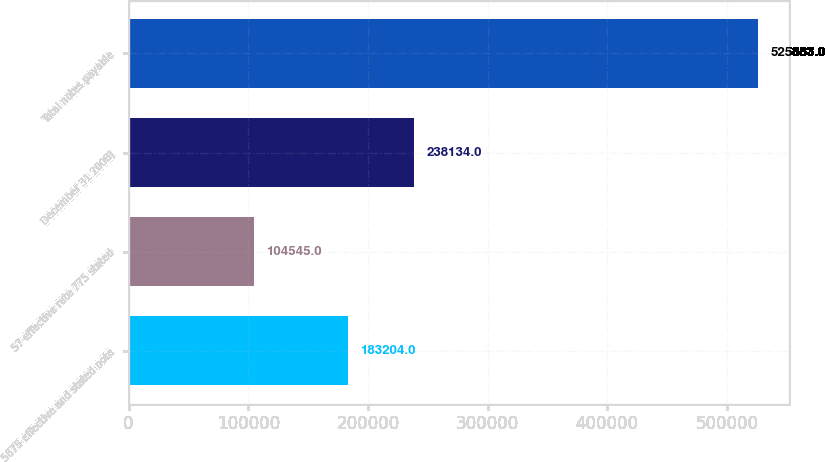Convert chart to OTSL. <chart><loc_0><loc_0><loc_500><loc_500><bar_chart><fcel>5875 effective and stated note<fcel>57 effective rate 775 stated<fcel>December 31 2008)<fcel>Total notes payable<nl><fcel>183204<fcel>104545<fcel>238134<fcel>525883<nl></chart> 